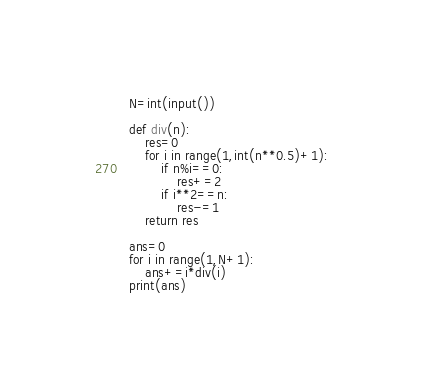<code> <loc_0><loc_0><loc_500><loc_500><_Python_>N=int(input())

def div(n):
    res=0
    for i in range(1,int(n**0.5)+1):
        if n%i==0:
            res+=2
        if i**2==n:
            res-=1
    return res

ans=0
for i in range(1,N+1):
    ans+=i*div(i)
print(ans)</code> 